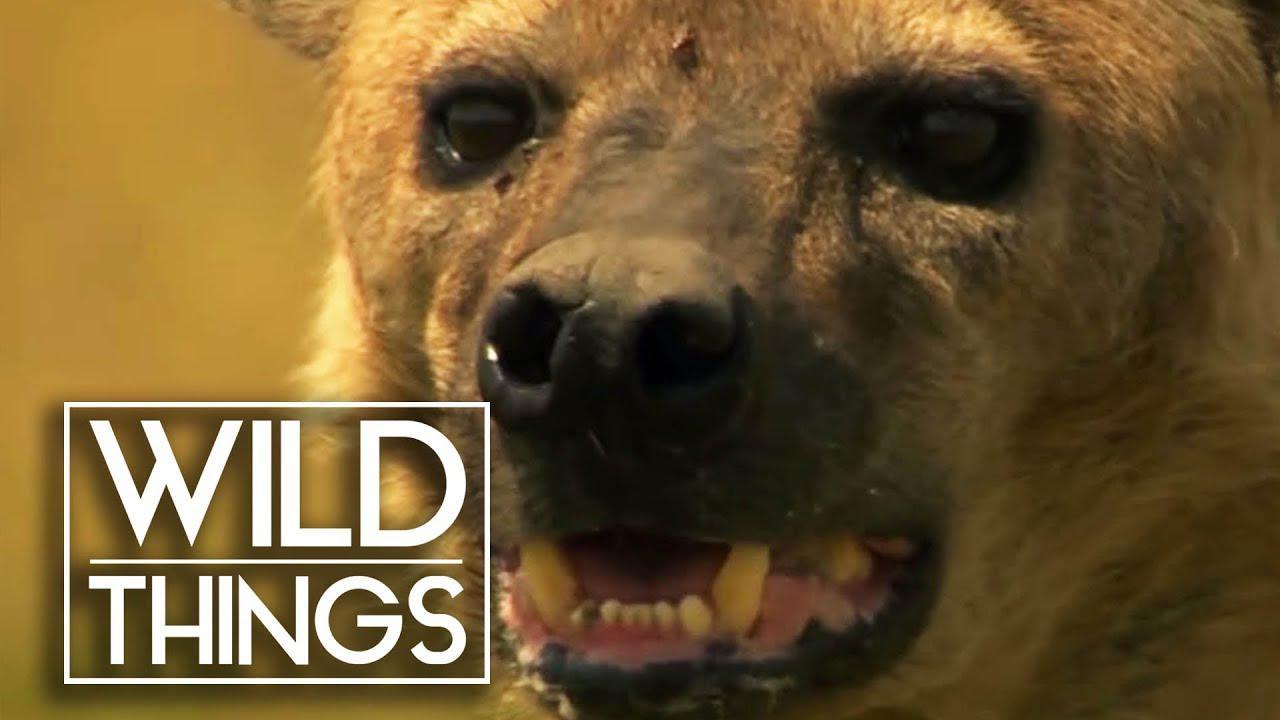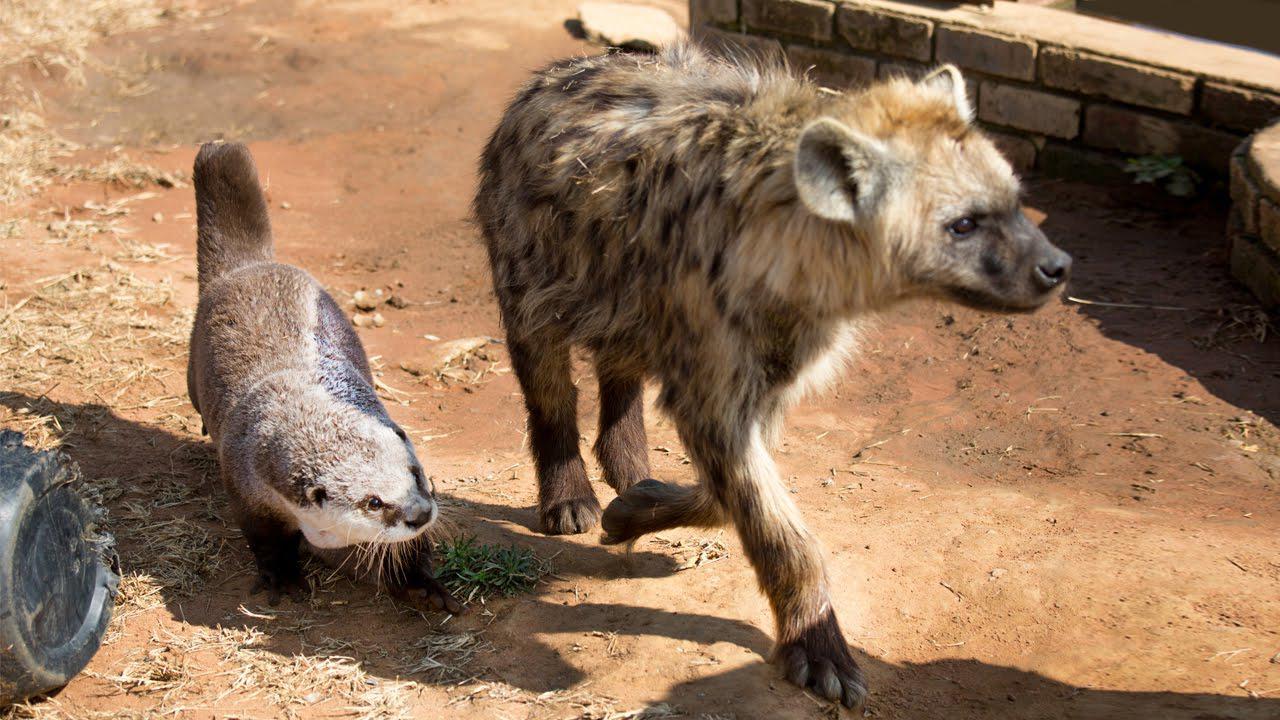The first image is the image on the left, the second image is the image on the right. Assess this claim about the two images: "In at least one image, a man is hugging a hyena.". Correct or not? Answer yes or no. No. The first image is the image on the left, the second image is the image on the right. Evaluate the accuracy of this statement regarding the images: "There are two men interacting with one or more large cats.". Is it true? Answer yes or no. No. 